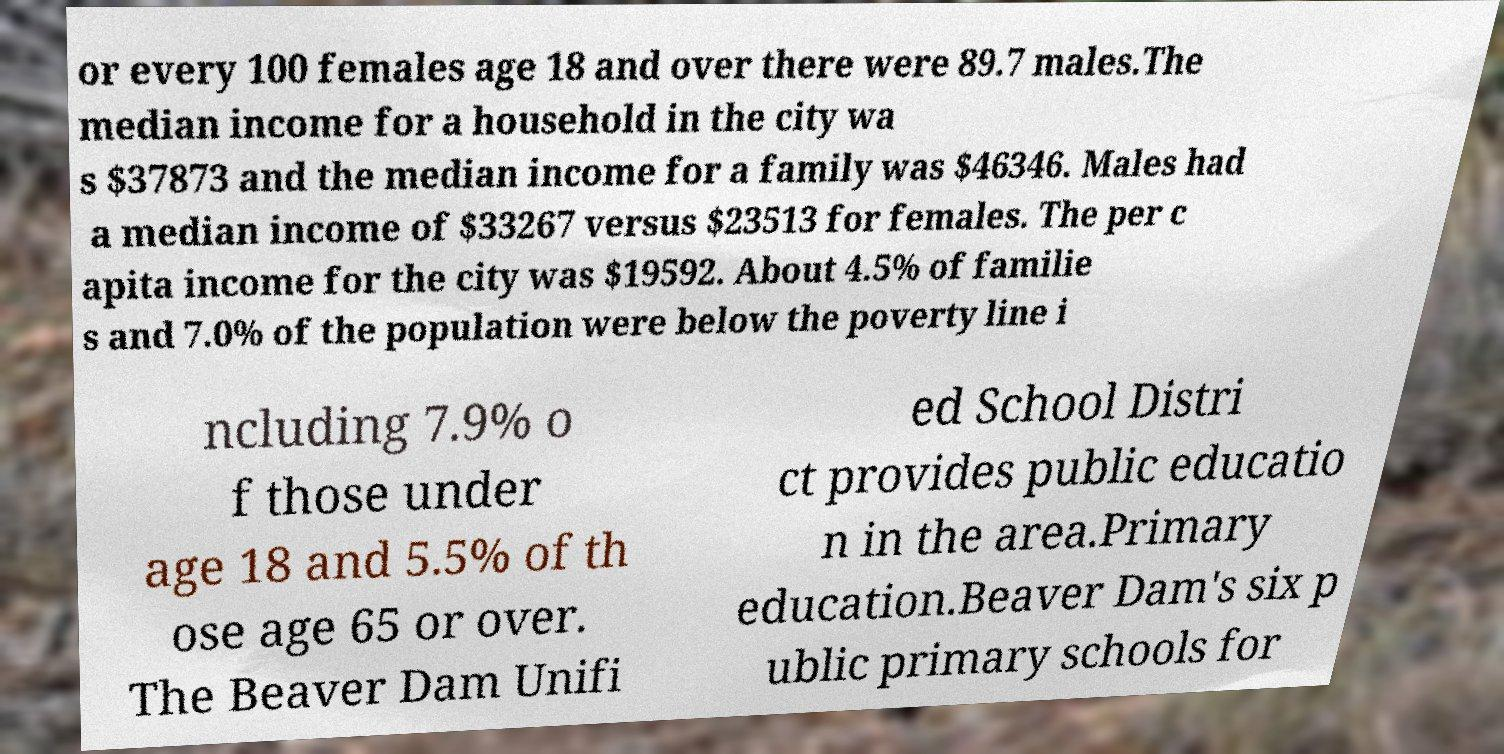What messages or text are displayed in this image? I need them in a readable, typed format. or every 100 females age 18 and over there were 89.7 males.The median income for a household in the city wa s $37873 and the median income for a family was $46346. Males had a median income of $33267 versus $23513 for females. The per c apita income for the city was $19592. About 4.5% of familie s and 7.0% of the population were below the poverty line i ncluding 7.9% o f those under age 18 and 5.5% of th ose age 65 or over. The Beaver Dam Unifi ed School Distri ct provides public educatio n in the area.Primary education.Beaver Dam's six p ublic primary schools for 